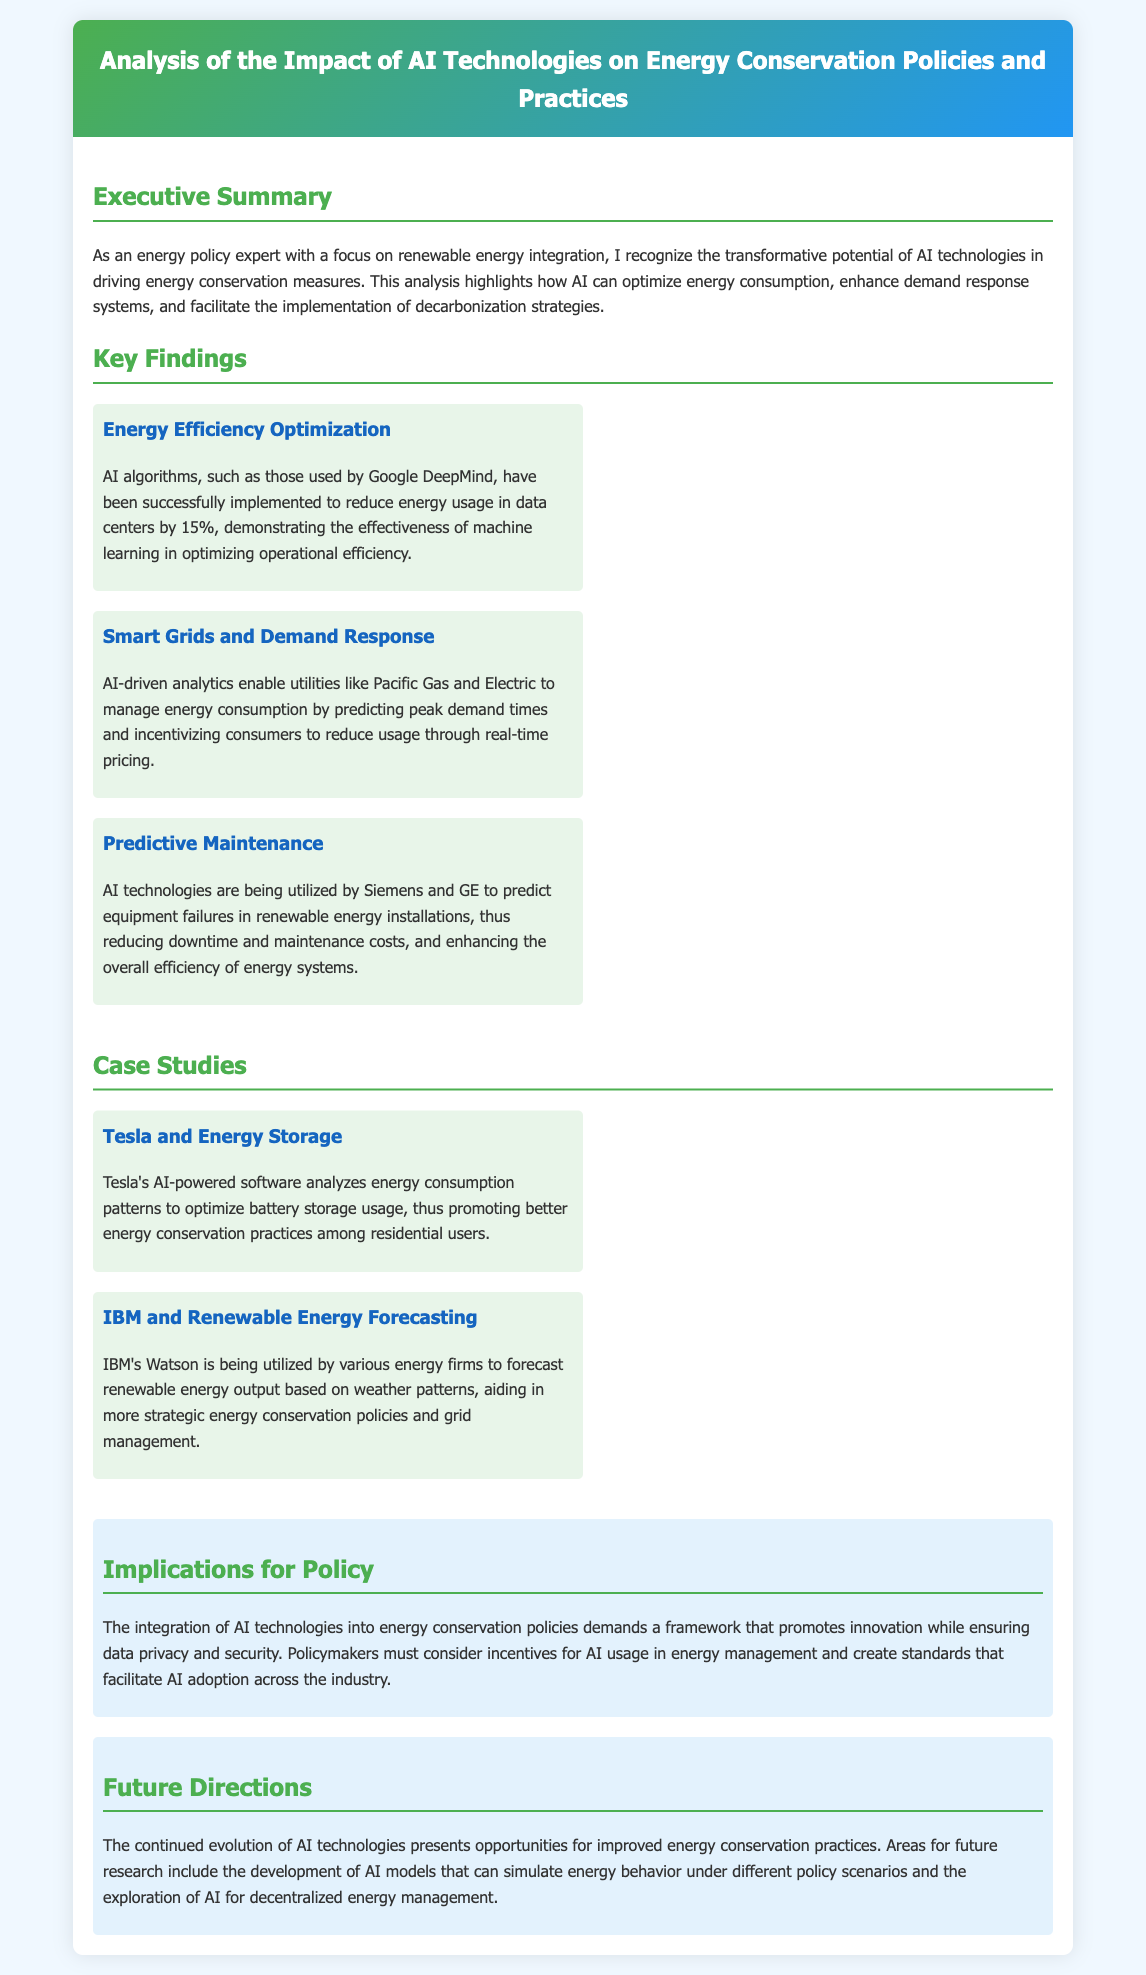what is the main focus of the analysis? The analysis highlights how AI can optimize energy consumption, enhance demand response systems, and facilitate the implementation of decarbonization strategies.
Answer: optimizing energy consumption who successfully implemented AI algorithms to reduce energy usage in data centers? Google DeepMind is mentioned in the key findings section related to energy efficiency optimization.
Answer: Google DeepMind what percentage of energy usage was reduced by AI in data centers? The document states that AI algorithms have been successfully implemented to reduce energy usage by 15%.
Answer: 15% which utility company uses AI-driven analytics to manage energy consumption? Pacific Gas and Electric is mentioned in relation to AI-driven analytics for demand response.
Answer: Pacific Gas and Electric what is one of the case studies mentioned in the document? Tesla's AI-powered software is cited as a case study related to energy storage.
Answer: Tesla and Energy Storage name a company that uses AI for predictive maintenance in renewable energy installations. Siemens and GE are both mentioned as utilizing AI for predictive maintenance.
Answer: Siemens and GE what is a major implication for policymakers regarding AI technologies? Policymakers must consider incentives for AI usage in energy management and create standards that facilitate AI adoption.
Answer: create standards what is a future research area mentioned in the document? The document suggests exploring the development of AI models that can simulate energy behavior under different policy scenarios as a future direction.
Answer: AI models for energy behavior simulation what color is used for the section titles in the document? The section titles are colored in a specific shade, mentioned in the style section.
Answer: green 